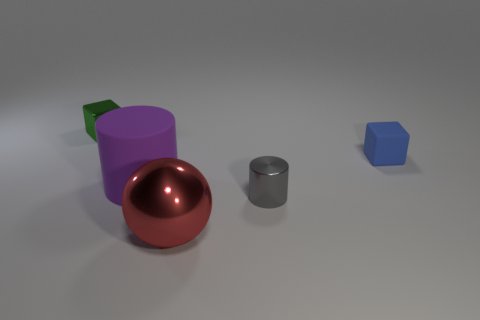How many things are either things that are right of the red ball or small metallic things?
Your answer should be compact. 3. Is there a gray ball of the same size as the gray metal cylinder?
Offer a terse response. No. Are there any tiny blue matte things that are in front of the tiny object right of the gray cylinder?
Offer a very short reply. No. What number of balls are either large things or purple things?
Make the answer very short. 1. Is there a large brown shiny thing that has the same shape as the gray object?
Offer a terse response. No. The big red thing has what shape?
Your answer should be compact. Sphere. What number of objects are small cylinders or large blue cylinders?
Make the answer very short. 1. Is the size of the cylinder that is on the left side of the shiny cylinder the same as the cylinder to the right of the big purple matte cylinder?
Give a very brief answer. No. How many other things are there of the same material as the small blue cube?
Give a very brief answer. 1. Is the number of gray objects that are in front of the small shiny cylinder greater than the number of big red metallic objects that are behind the tiny green object?
Keep it short and to the point. No. 